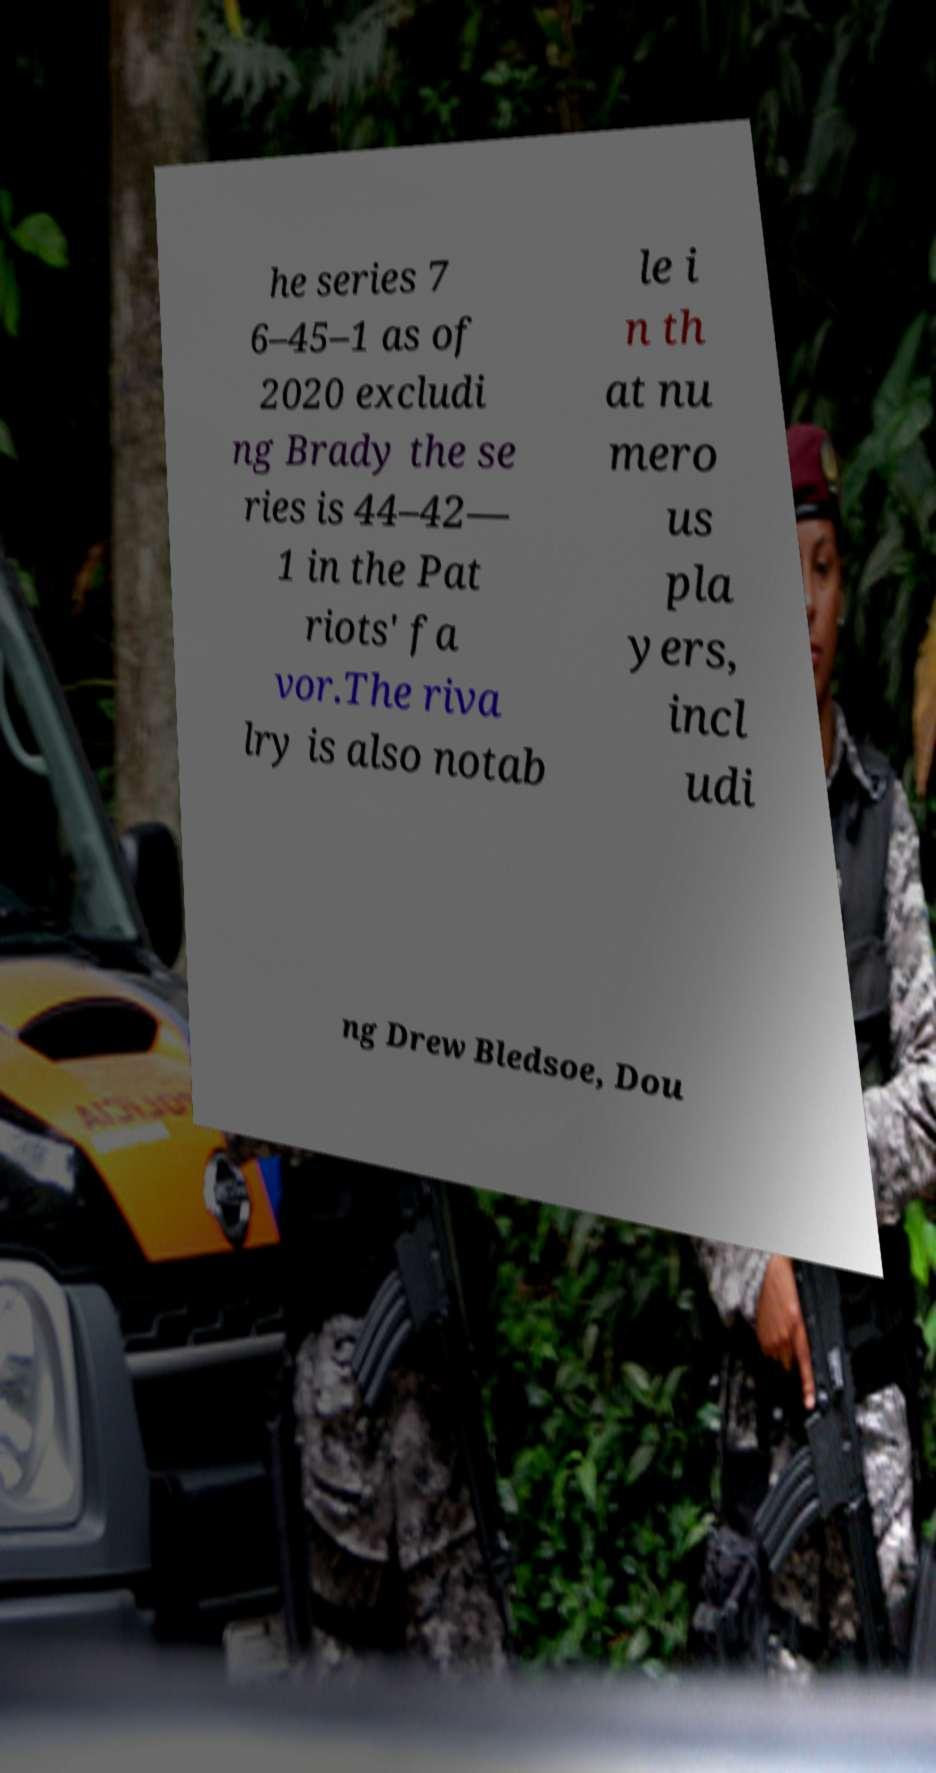What messages or text are displayed in this image? I need them in a readable, typed format. he series 7 6–45–1 as of 2020 excludi ng Brady the se ries is 44–42— 1 in the Pat riots' fa vor.The riva lry is also notab le i n th at nu mero us pla yers, incl udi ng Drew Bledsoe, Dou 